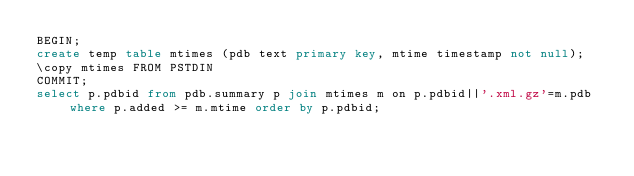Convert code to text. <code><loc_0><loc_0><loc_500><loc_500><_SQL_>BEGIN;
create temp table mtimes (pdb text primary key, mtime timestamp not null);
\copy mtimes FROM PSTDIN
COMMIT;
select p.pdbid from pdb.summary p join mtimes m on p.pdbid||'.xml.gz'=m.pdb where p.added >= m.mtime order by p.pdbid;
</code> 